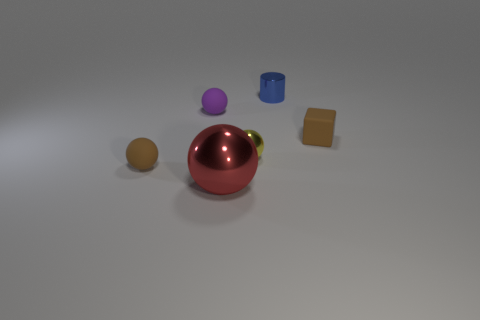Subtract all red metal balls. How many balls are left? 3 Add 4 purple rubber balls. How many objects exist? 10 Subtract all purple cubes. Subtract all yellow balls. How many cubes are left? 1 Subtract all gray cylinders. How many red spheres are left? 1 Subtract all big green metallic cylinders. Subtract all small metallic spheres. How many objects are left? 5 Add 4 cubes. How many cubes are left? 5 Add 6 small metallic cylinders. How many small metallic cylinders exist? 7 Subtract 1 brown cubes. How many objects are left? 5 Subtract all cylinders. How many objects are left? 5 